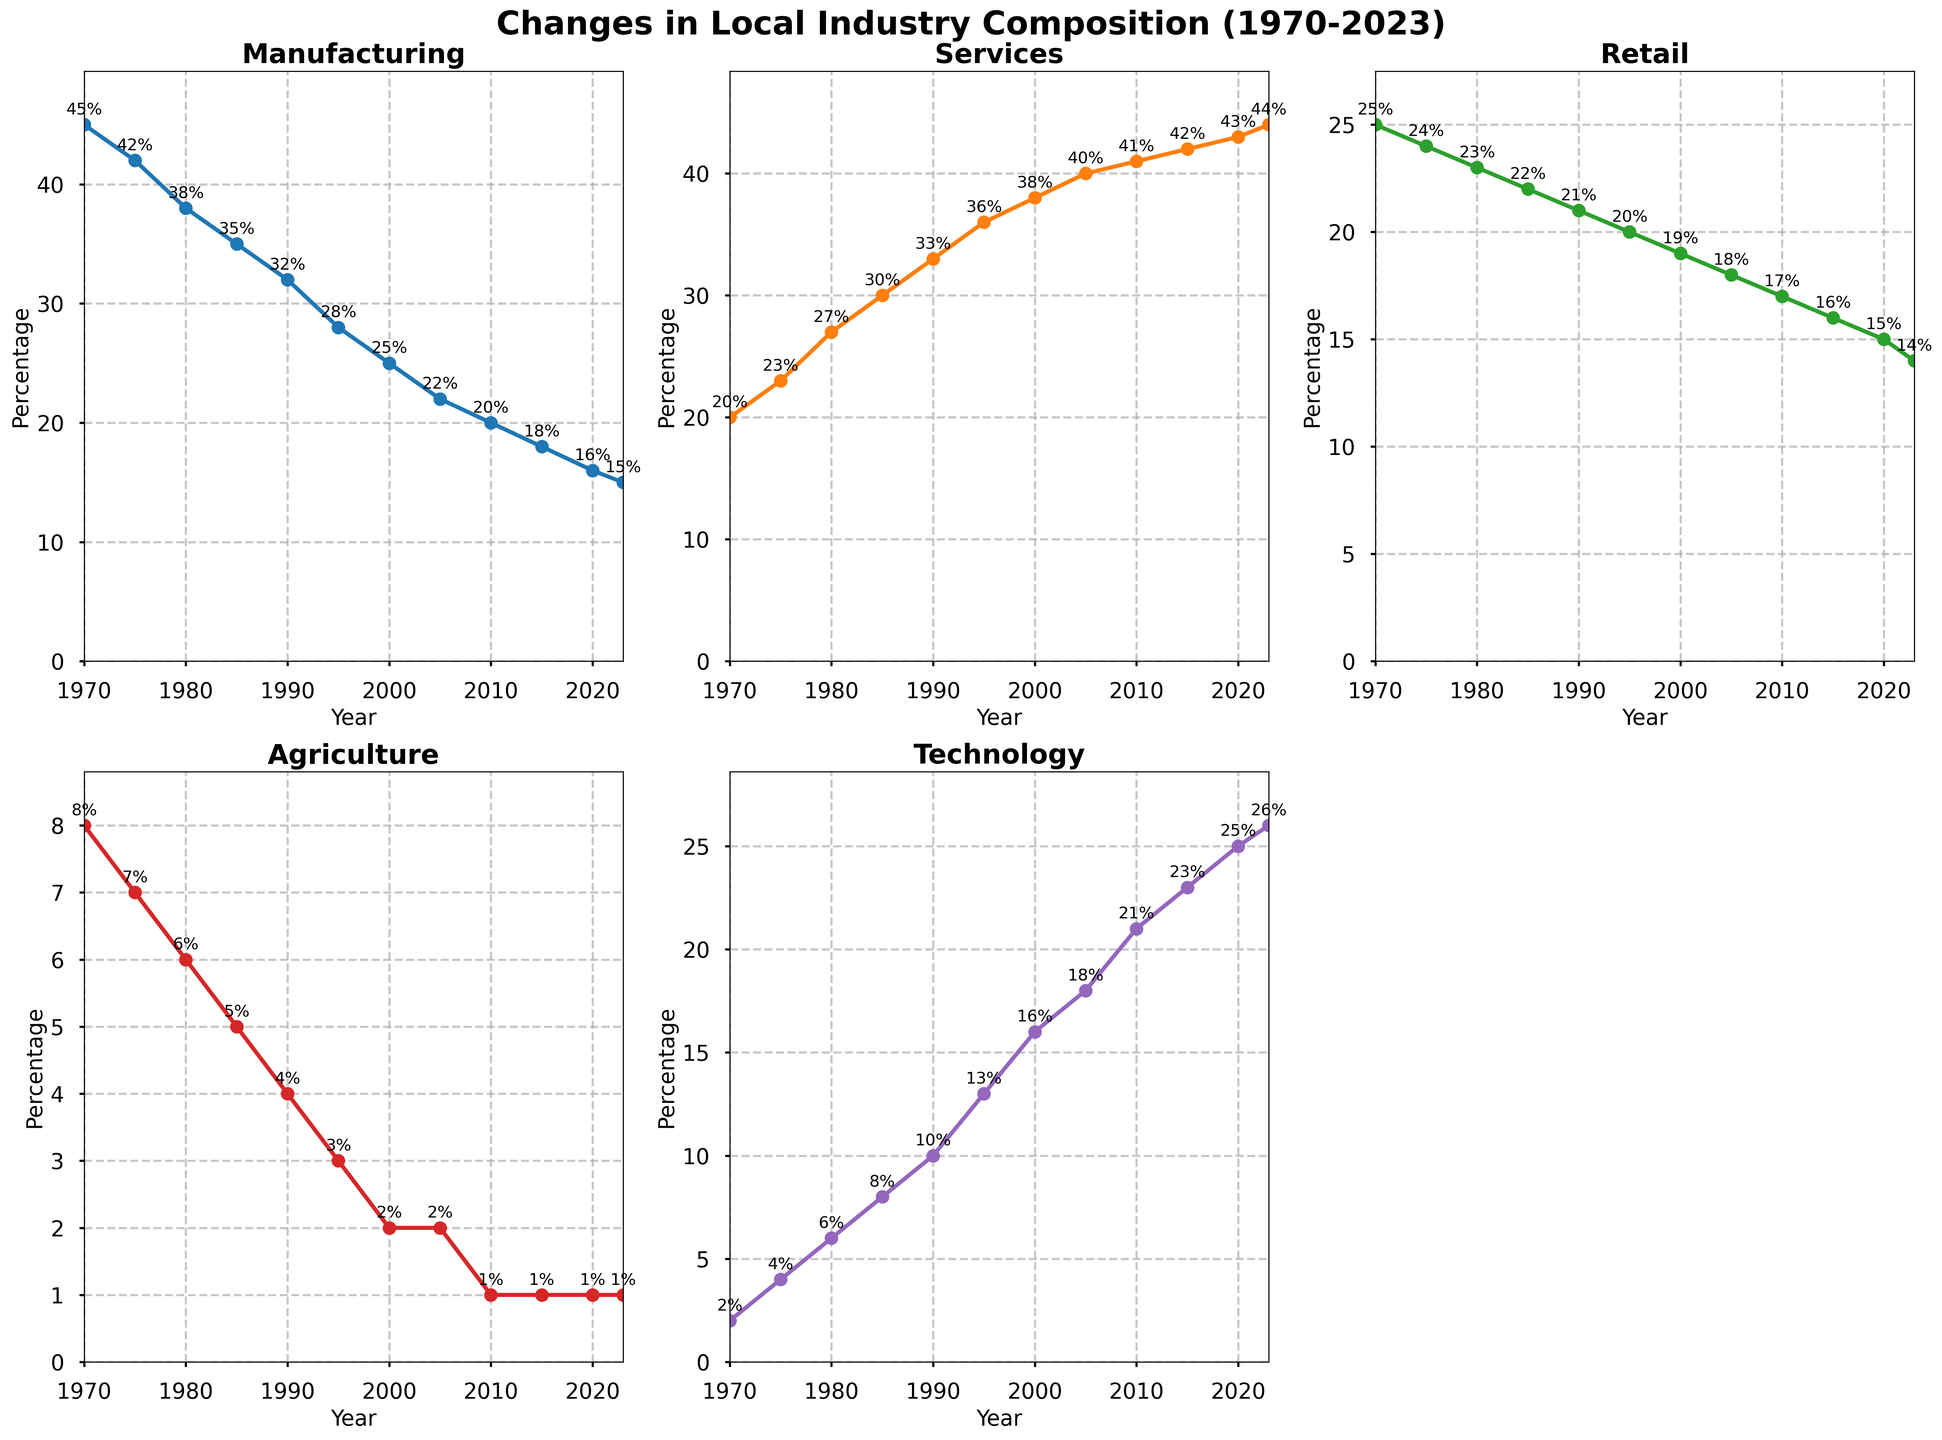What has been the overall trend in the Manufacturing sector from 1970 to 2023? By observing the Manufacturing plot, the percentage has steadily decreased from 45% in 1970 to 15% in 2023.
Answer: Steady decrease Which sector had the highest percentage increase from 1970 to 2023? The Technology plot shows the largest increase, starting from 2% in 1970 and rising to 26% in 2023. The other sectors either decreased or had smaller increases.
Answer: Technology In what year did Services surpass Manufacturing in employment percentage? By comparing the Services and Manufacturing plots, Services surpassed Manufacturing in 1980 when Services was at 27% and Manufacturing at 38%.
Answer: 1980 Calculate the sum of percentages for Services and Technology in 2023. In 2023, Services is at 44% and Technology is at 26%. Adding these gives 44 + 26 = 70%.
Answer: 70% How has the percentage of the Retail sector changed from 1970 to 2023? The Retail sector's plot shows a decrease from 25% in 1970 to 14% in 2023.
Answer: Decrease Which sector had the highest percentage in 2000, and what was its value? The Services plot in 2000 shows the highest percentage at 38%, higher than other sectors.
Answer: Services, 38% Compare the trend in the Agriculture sector to the Technology sector from 1970 to 2023. The Agriculture sector consistently decreased from 8% in 1970 to 1% in 2023, while the Technology sector increased from 2% to 26% during the same period, showing opposite trends.
Answer: Opposite trends What is the average percentage of the Services sector from 1970 to 2023? The percentages from 1970 to 2023 (20, 23, 27, 30, 33, 36, 38, 40, 41, 42, 43, 44) sum up to 417. Dividing this by 12 gives the average: 417 / 12 ≈ 34.75%
Answer: ~34.75% Identify the years where the Retail sector percentage was exactly equal to that of the Manufacturing sector. By examining the plot details, there is no year where the percentages of Retail and Manufacturing are exactly equal.
Answer: None In which decade did the Technology sector see the greatest percentage increase? The Technology sector plot shows the largest increase occurred from 2000 to 2010, rising from 16% to 21%, an increase of 5%.
Answer: 2000-2010 